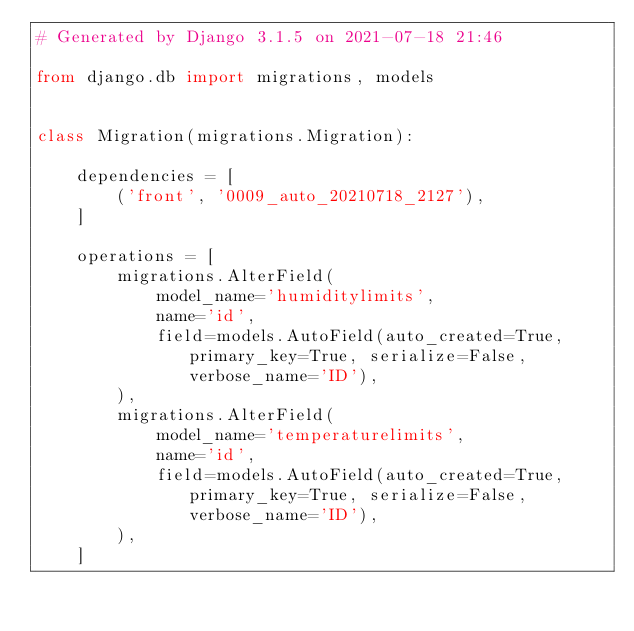Convert code to text. <code><loc_0><loc_0><loc_500><loc_500><_Python_># Generated by Django 3.1.5 on 2021-07-18 21:46

from django.db import migrations, models


class Migration(migrations.Migration):

    dependencies = [
        ('front', '0009_auto_20210718_2127'),
    ]

    operations = [
        migrations.AlterField(
            model_name='humiditylimits',
            name='id',
            field=models.AutoField(auto_created=True, primary_key=True, serialize=False, verbose_name='ID'),
        ),
        migrations.AlterField(
            model_name='temperaturelimits',
            name='id',
            field=models.AutoField(auto_created=True, primary_key=True, serialize=False, verbose_name='ID'),
        ),
    ]
</code> 